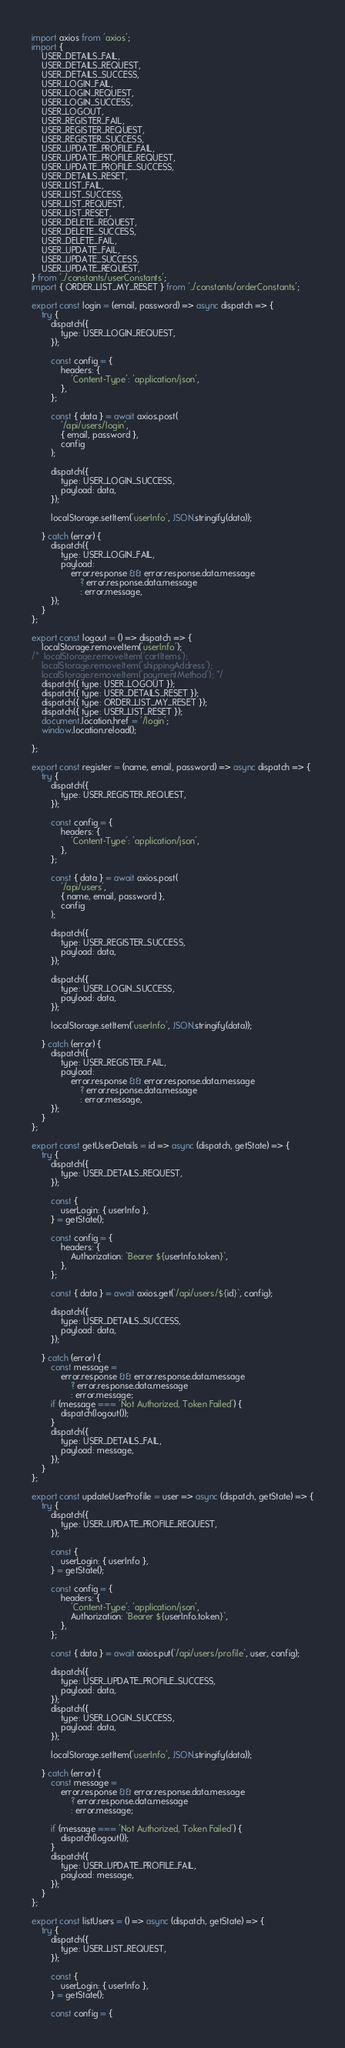Convert code to text. <code><loc_0><loc_0><loc_500><loc_500><_JavaScript_>import axios from 'axios';
import {
	USER_DETAILS_FAIL,
	USER_DETAILS_REQUEST,
	USER_DETAILS_SUCCESS,
	USER_LOGIN_FAIL,
	USER_LOGIN_REQUEST,
	USER_LOGIN_SUCCESS,
	USER_LOGOUT,
	USER_REGISTER_FAIL,
	USER_REGISTER_REQUEST,
	USER_REGISTER_SUCCESS,
	USER_UPDATE_PROFILE_FAIL,
	USER_UPDATE_PROFILE_REQUEST,
	USER_UPDATE_PROFILE_SUCCESS,
	USER_DETAILS_RESET,
	USER_LIST_FAIL,
	USER_LIST_SUCCESS,
	USER_LIST_REQUEST,
	USER_LIST_RESET,
	USER_DELETE_REQUEST,
	USER_DELETE_SUCCESS,
	USER_DELETE_FAIL,
	USER_UPDATE_FAIL,
	USER_UPDATE_SUCCESS,
	USER_UPDATE_REQUEST,
} from '../constants/userConstants';
import { ORDER_LIST_MY_RESET } from '../constants/orderConstants';

export const login = (email, password) => async dispatch => {
	try {
		dispatch({
			type: USER_LOGIN_REQUEST,
		});

		const config = {
			headers: {
				'Content-Type': 'application/json',
			},
		};

		const { data } = await axios.post(
			'/api/users/login',
			{ email, password },
			config
		);

		dispatch({
			type: USER_LOGIN_SUCCESS,
			payload: data,
		});

		localStorage.setItem('userInfo', JSON.stringify(data));

	} catch (error) {
		dispatch({
			type: USER_LOGIN_FAIL,
			payload:
				error.response && error.response.data.message
					? error.response.data.message
					: error.message,
		});
	}
};

export const logout = () => dispatch => {
	localStorage.removeItem('userInfo');
/* 	localStorage.removeItem('cartItems');
	localStorage.removeItem('shippingAddress');
	localStorage.removeItem('paymentMethod'); */
	dispatch({ type: USER_LOGOUT });
	dispatch({ type: USER_DETAILS_RESET });
	dispatch({ type: ORDER_LIST_MY_RESET });
	dispatch({ type: USER_LIST_RESET });
	document.location.href = '/login';
	window.location.reload();

};

export const register = (name, email, password) => async dispatch => {
	try {
		dispatch({
			type: USER_REGISTER_REQUEST,
		});

		const config = {
			headers: {
				'Content-Type': 'application/json',
			},
		};

		const { data } = await axios.post(
			'/api/users',
			{ name, email, password },
			config
		);

		dispatch({
			type: USER_REGISTER_SUCCESS,
			payload: data,
		});

		dispatch({
			type: USER_LOGIN_SUCCESS,
			payload: data,
		});

		localStorage.setItem('userInfo', JSON.stringify(data));

	} catch (error) {
		dispatch({
			type: USER_REGISTER_FAIL,
			payload:
				error.response && error.response.data.message
					? error.response.data.message
					: error.message,
		});
	}
};

export const getUserDetails = id => async (dispatch, getState) => {
	try {
		dispatch({
			type: USER_DETAILS_REQUEST,
		});

		const {
			userLogin: { userInfo },
		} = getState();

		const config = {
			headers: {
				Authorization: `Bearer ${userInfo.token}`,
			},
		};

		const { data } = await axios.get(`/api/users/${id}`, config);

		dispatch({
			type: USER_DETAILS_SUCCESS,
			payload: data,
		});
		
	} catch (error) {
		const message =
			error.response && error.response.data.message
				? error.response.data.message
				: error.message;
		if (message === 'Not Authorized, Token Failed') {
			dispatch(logout());
		}
		dispatch({
			type: USER_DETAILS_FAIL,
			payload: message,
		});
	}
};

export const updateUserProfile = user => async (dispatch, getState) => {
	try {
		dispatch({
			type: USER_UPDATE_PROFILE_REQUEST,
		});

		const {
			userLogin: { userInfo },
		} = getState();

		const config = {
			headers: {
				'Content-Type': 'application/json',
				Authorization: `Bearer ${userInfo.token}`,
			},
		};

		const { data } = await axios.put(`/api/users/profile`, user, config);

		dispatch({
			type: USER_UPDATE_PROFILE_SUCCESS,
			payload: data,
		});
		dispatch({
			type: USER_LOGIN_SUCCESS,
			payload: data,
		});

		localStorage.setItem('userInfo', JSON.stringify(data));

	} catch (error) {
		const message =
			error.response && error.response.data.message
				? error.response.data.message
				: error.message;
				
		if (message === 'Not Authorized, Token Failed') {
			dispatch(logout());
		}
		dispatch({
			type: USER_UPDATE_PROFILE_FAIL,
			payload: message,
		});
	}
};

export const listUsers = () => async (dispatch, getState) => {
	try {
		dispatch({
			type: USER_LIST_REQUEST,
		});

		const {
			userLogin: { userInfo },
		} = getState();

		const config = {</code> 